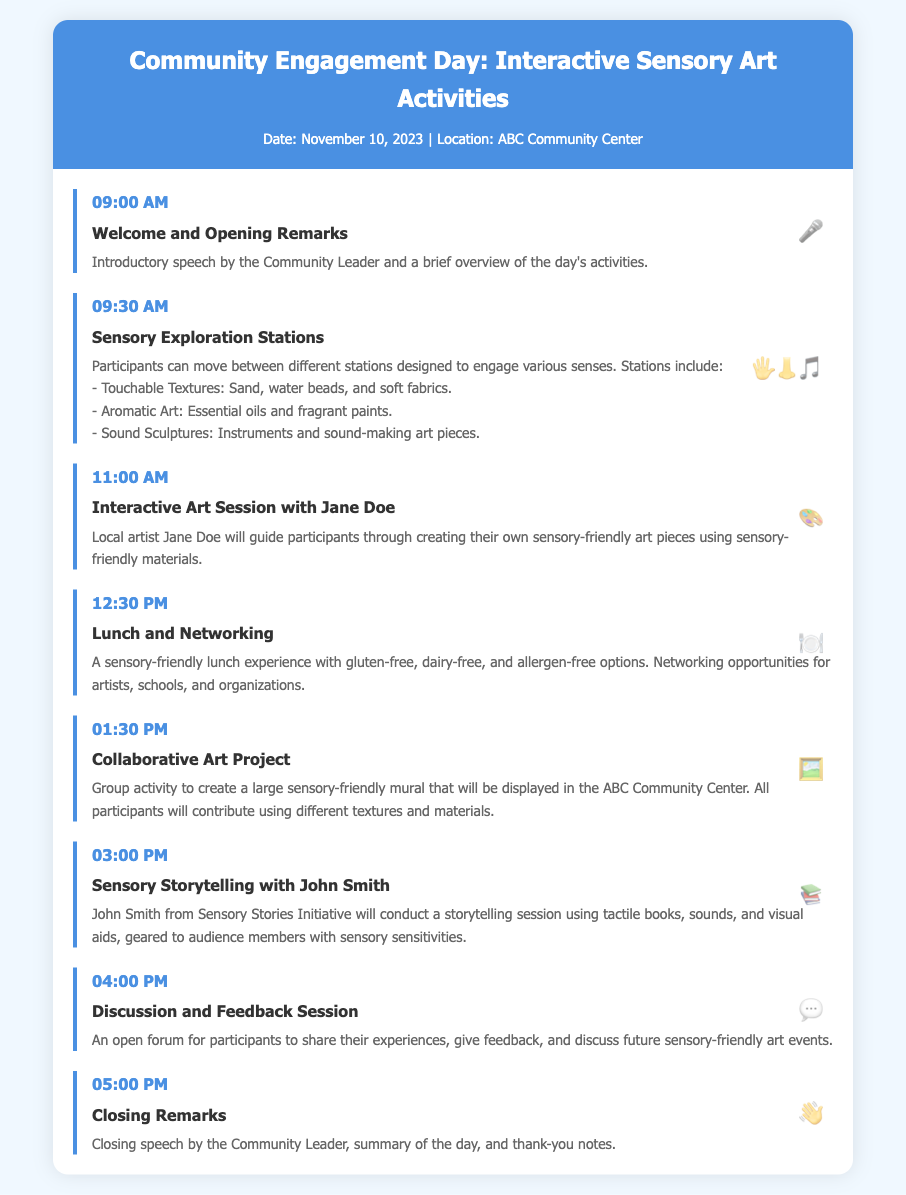What is the date of the event? The document explicitly states the date of the event as November 10, 2023.
Answer: November 10, 2023 What time does the "Welcome and Opening Remarks" start? The itinerary lists the start time for "Welcome and Opening Remarks" as 09:00 AM.
Answer: 09:00 AM Who is conducting the storytelling session? The itinerary mentions John Smith from the Sensory Stories Initiative as the conductor of the storytelling session.
Answer: John Smith What type of lunch is provided? The document describes the lunch as sensory-friendly with various dietary options available.
Answer: Sensory-friendly What will participants create during the "Collaborative Art Project"? The activity description states that participants will create a large sensory-friendly mural.
Answer: A large sensory-friendly mural What is the last activity scheduled for the day? The final activity listed in the itinerary is "Closing Remarks."
Answer: Closing Remarks How long is the Interactive Art Session? The session starts at 11:00 AM and ends at 12:30 PM, which means it lasts for 1 hour and 30 minutes.
Answer: 1 hour and 30 minutes What kind of materials will Jane Doe use in the Interactive Art Session? The document states that sensory-friendly materials will be used during the session.
Answer: Sensory-friendly materials 